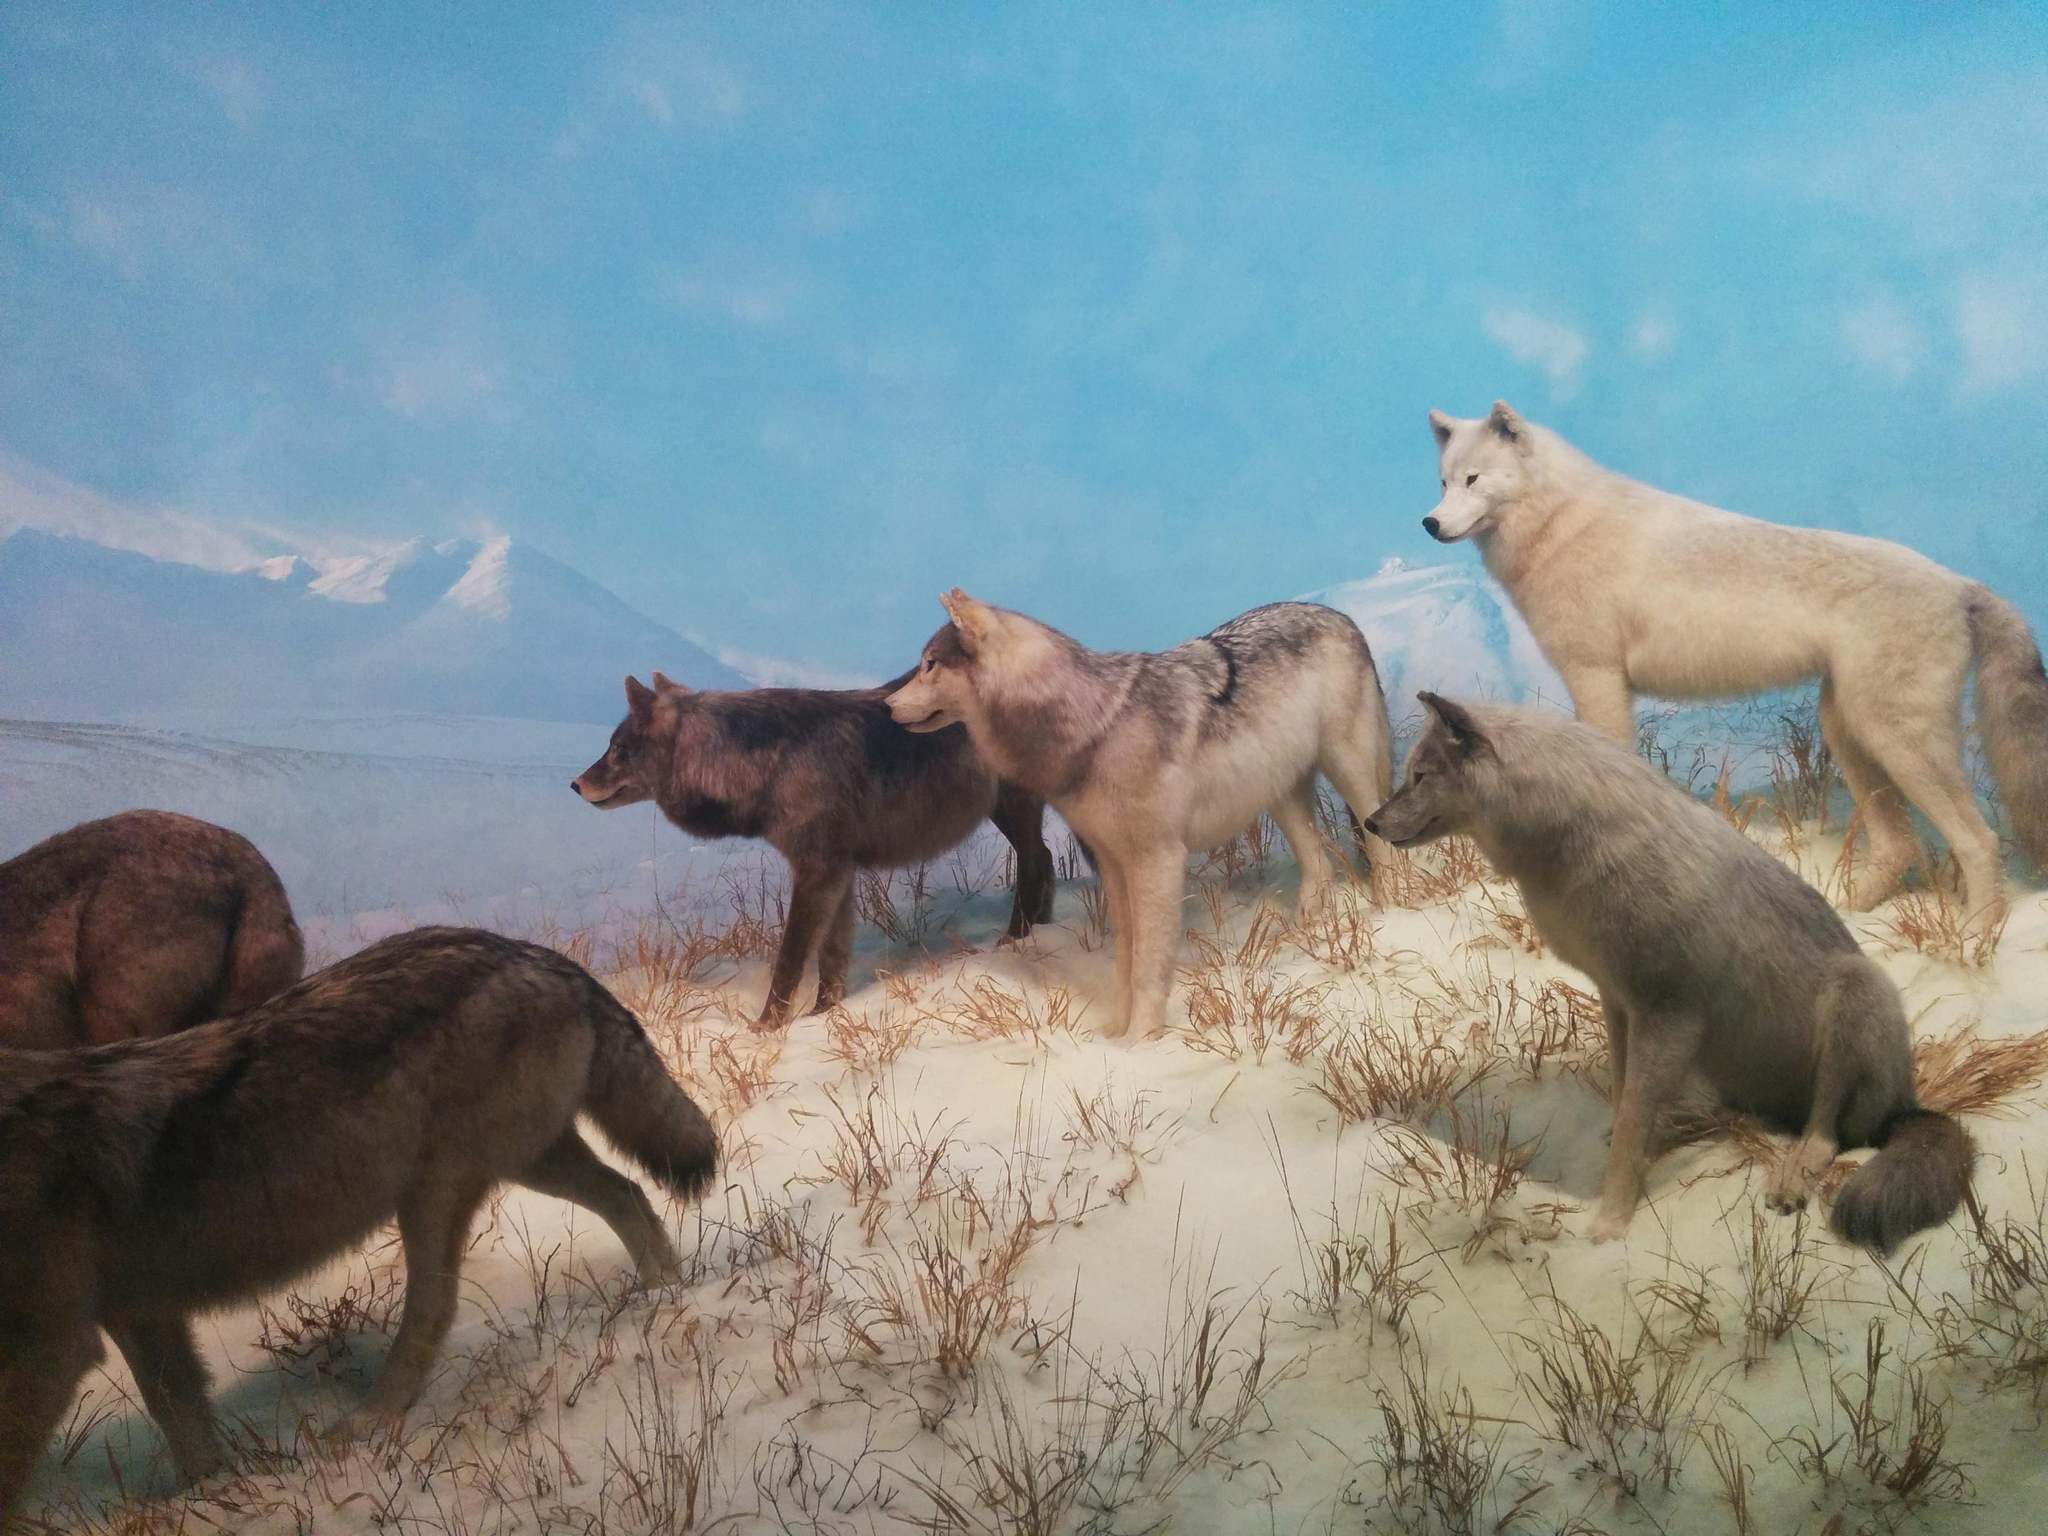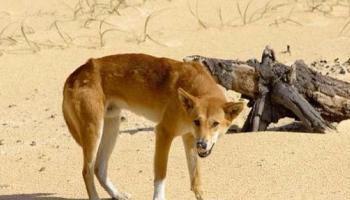The first image is the image on the left, the second image is the image on the right. Assess this claim about the two images: "An image shows multiple dogs reclining near some type of tree log.". Correct or not? Answer yes or no. No. 